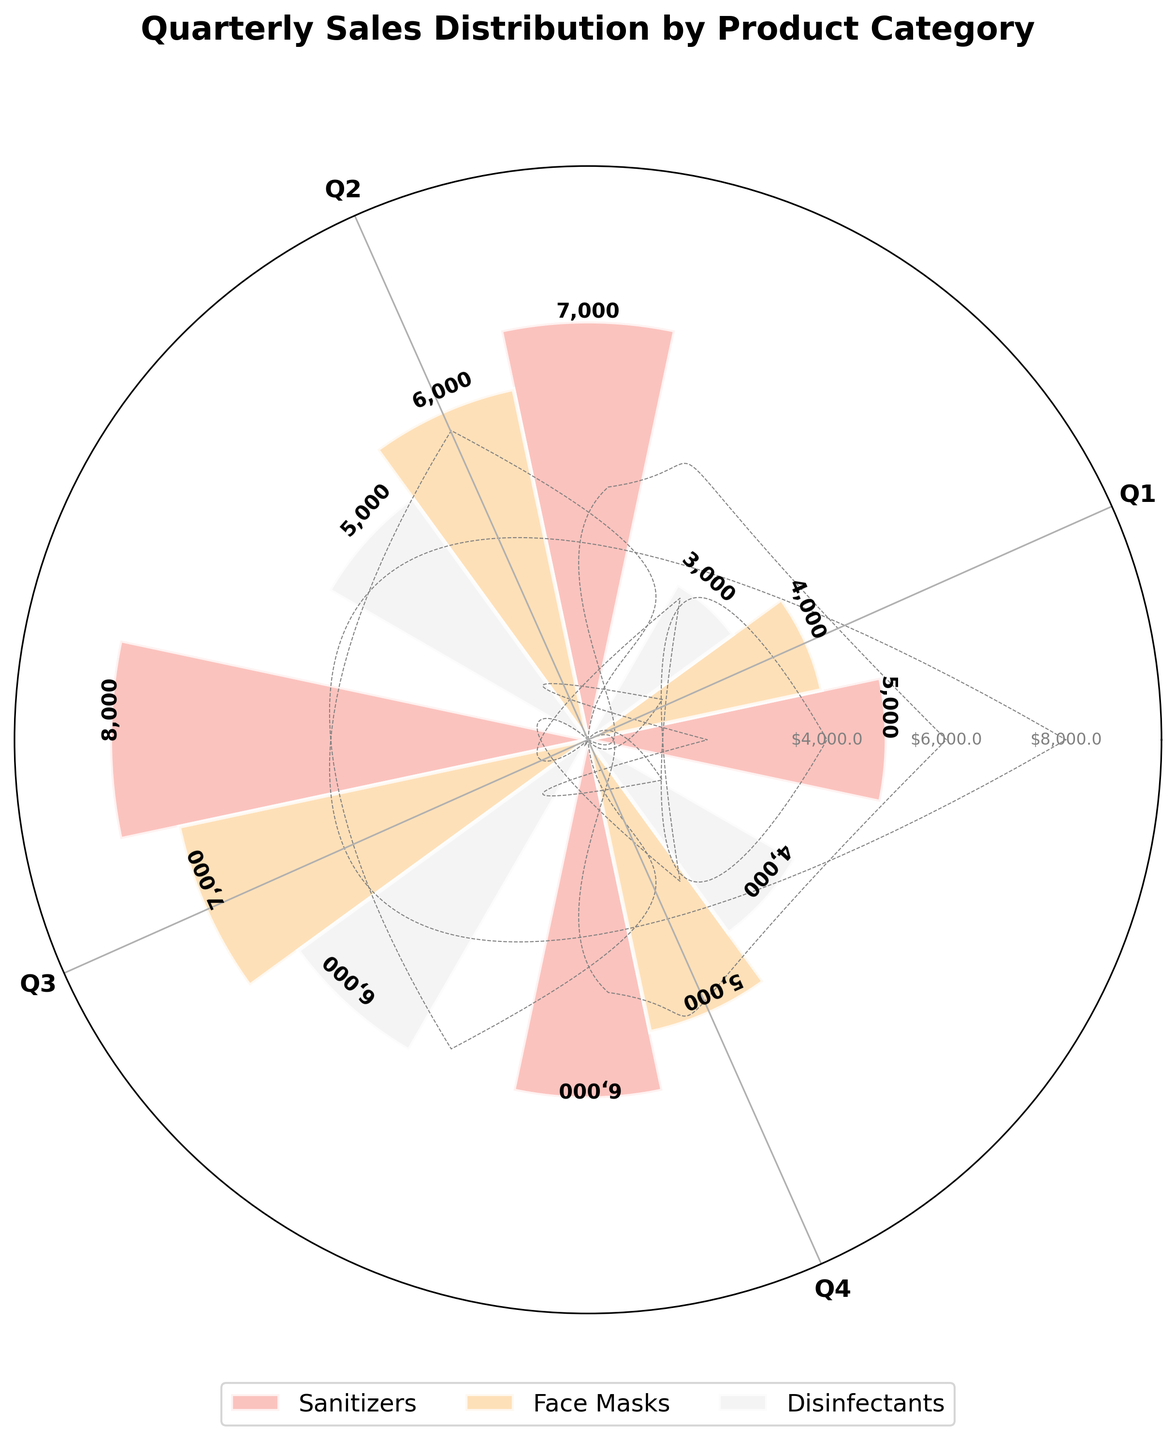What's the title of the figure? The title is prominently displayed at the top of the figure. It reads "Quarterly Sales Distribution by Product Category".
Answer: Quarterly Sales Distribution by Product Category How many product categories are included in the figure? By observing the legend or the number of distinct colors, we see there are three product categories represented in the figure.
Answer: Three Which quarter has the highest sales of sanitizers? We look at the bars corresponding to "Sanitizers" and compare their heights. The highest bar for sanitizers is in Q3.
Answer: Q3 What are the sales amounts for face masks in Q2 and Q4? We find the bars representing face masks in Q2 and Q4 and note their heights, which are labeled. The sales amounts are $6,000 in Q2 and $5,000 in Q4.
Answer: $6,000, $5,000 Which product category has the lowest sales in Q1? Compare the bar heights for Q1 across all categories. Disinfectants have the lowest bar in Q1.
Answer: Disinfectants What is the total sales amount for disinfectants over all quarters? Add the sales amounts for disinfectants in each quarter: $3,000 + $5,000 + $6,000 + $4,000.
Answer: $18,000 Which product had the highest total sales in the year? Sum the sales for each product across all quarters and compare. Sanitizers have the highest total sales: $26,000 for Sanitizers, $22,000 for Face Masks, and $18,000 for Disinfectants.
Answer: Sanitizers How do Q4 sales of face masks compare to Q4 sales of sanitizers? Look at the Q4 bars for face masks and sanitizers. Q4 sales for face masks ($5,000) are lower than for sanitizers ($6,000).
Answer: Face masks have lower sales What is the average sales amount per quarter for sanitizers? Add the quarterly sales amounts for sanitizers: $5,000 + $7,000 + $8,000 + $6,000, then divide by 4. The average is ($26,000/4).
Answer: $6,500 In which quarters do face masks and disinfectants have equal sales? Compare the bar heights for face masks and disinfectants across quarters. Both have equal sales ($5,000) in Q2.
Answer: Q2 